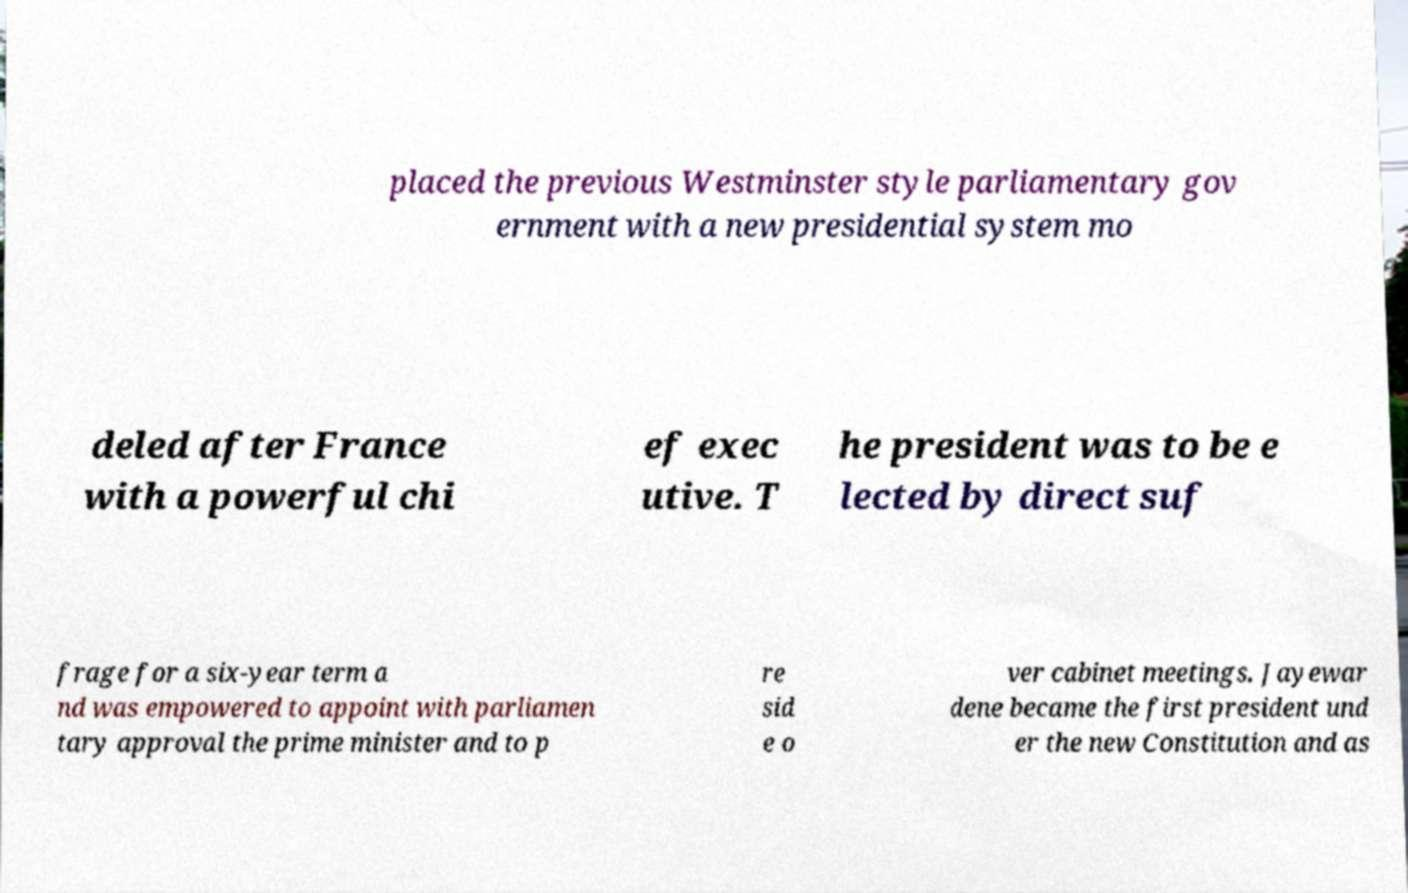Could you assist in decoding the text presented in this image and type it out clearly? placed the previous Westminster style parliamentary gov ernment with a new presidential system mo deled after France with a powerful chi ef exec utive. T he president was to be e lected by direct suf frage for a six-year term a nd was empowered to appoint with parliamen tary approval the prime minister and to p re sid e o ver cabinet meetings. Jayewar dene became the first president und er the new Constitution and as 